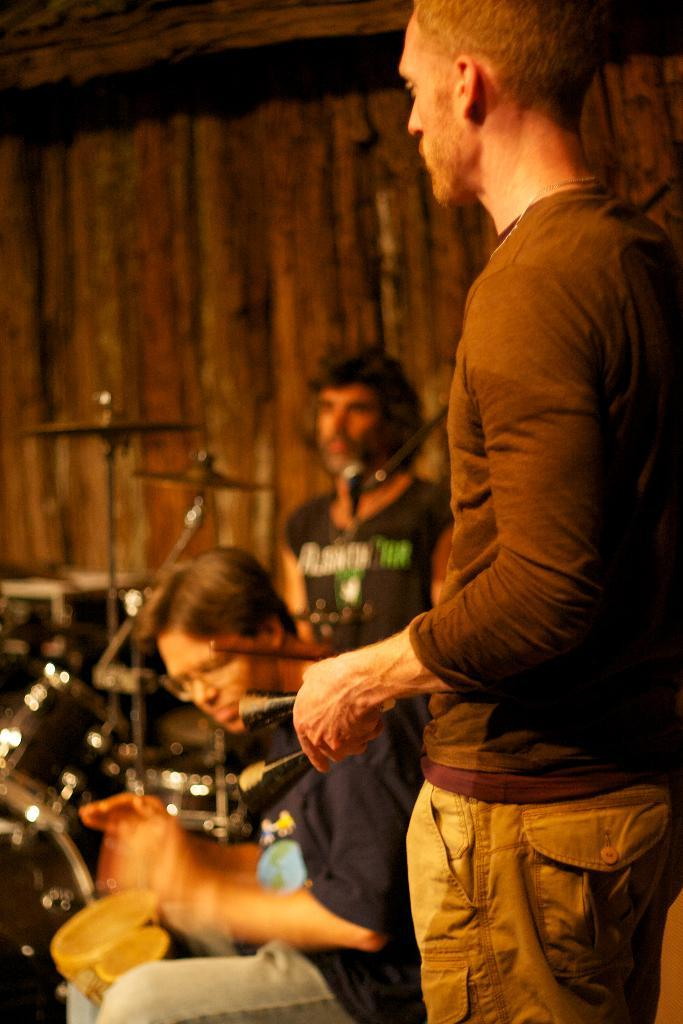How many musicians are in the image? There are three musicians in the image. What instruments are the musicians playing? The musicians are playing drums and tabla. What type of letters are being written on the calendar in the image? There is no calendar or letters present in the image; it features three musicians playing drums and tabla. 